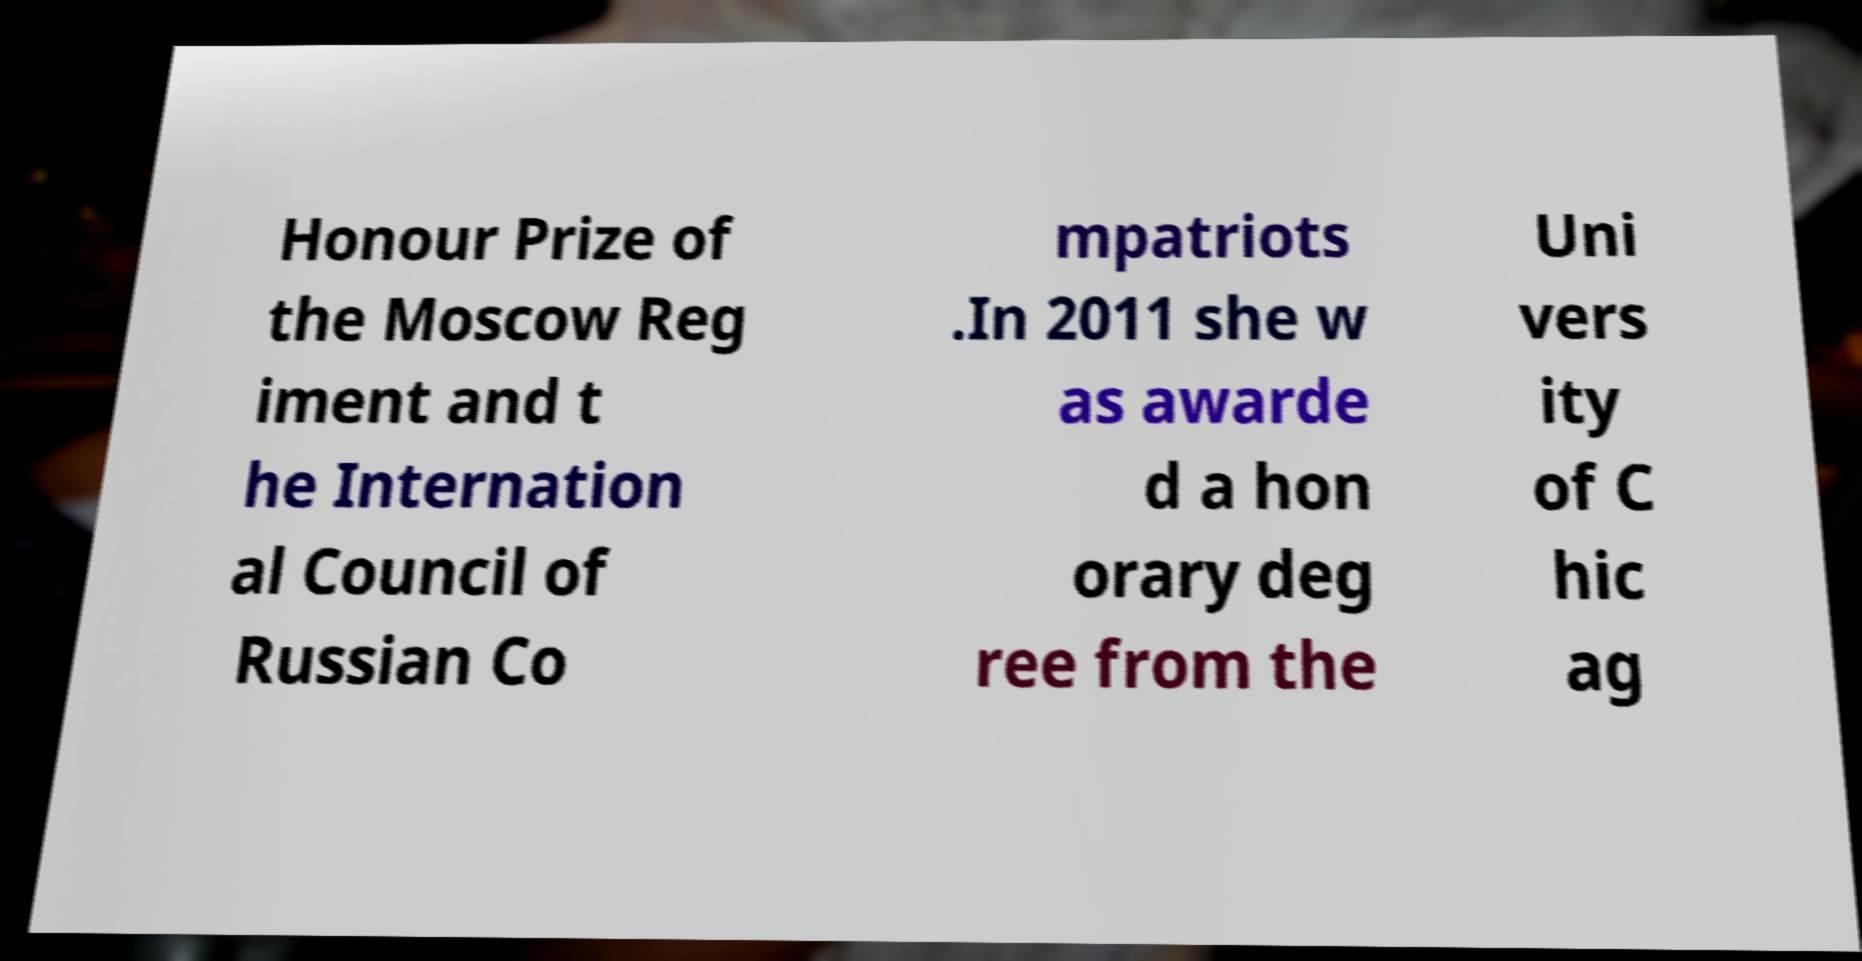I need the written content from this picture converted into text. Can you do that? Honour Prize of the Moscow Reg iment and t he Internation al Council of Russian Co mpatriots .In 2011 she w as awarde d a hon orary deg ree from the Uni vers ity of C hic ag 